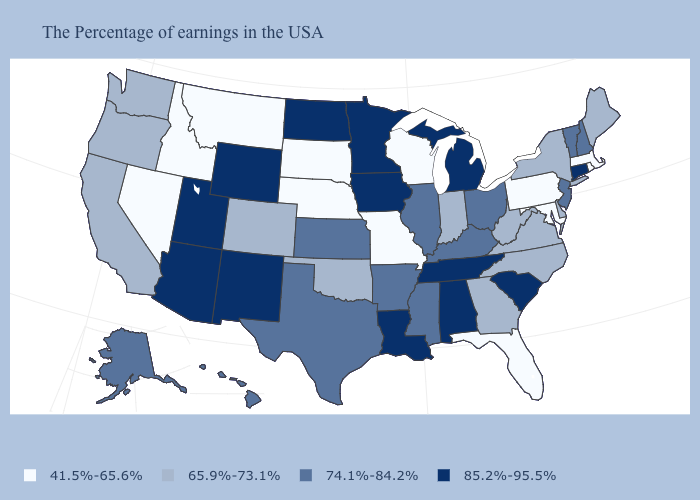What is the value of California?
Give a very brief answer. 65.9%-73.1%. How many symbols are there in the legend?
Be succinct. 4. Which states have the lowest value in the West?
Answer briefly. Montana, Idaho, Nevada. Name the states that have a value in the range 41.5%-65.6%?
Write a very short answer. Massachusetts, Rhode Island, Maryland, Pennsylvania, Florida, Wisconsin, Missouri, Nebraska, South Dakota, Montana, Idaho, Nevada. Name the states that have a value in the range 41.5%-65.6%?
Be succinct. Massachusetts, Rhode Island, Maryland, Pennsylvania, Florida, Wisconsin, Missouri, Nebraska, South Dakota, Montana, Idaho, Nevada. What is the value of South Dakota?
Be succinct. 41.5%-65.6%. Name the states that have a value in the range 74.1%-84.2%?
Short answer required. New Hampshire, Vermont, New Jersey, Ohio, Kentucky, Illinois, Mississippi, Arkansas, Kansas, Texas, Alaska, Hawaii. Name the states that have a value in the range 41.5%-65.6%?
Short answer required. Massachusetts, Rhode Island, Maryland, Pennsylvania, Florida, Wisconsin, Missouri, Nebraska, South Dakota, Montana, Idaho, Nevada. Name the states that have a value in the range 41.5%-65.6%?
Concise answer only. Massachusetts, Rhode Island, Maryland, Pennsylvania, Florida, Wisconsin, Missouri, Nebraska, South Dakota, Montana, Idaho, Nevada. Among the states that border South Dakota , which have the lowest value?
Write a very short answer. Nebraska, Montana. Does Montana have the lowest value in the West?
Concise answer only. Yes. What is the lowest value in states that border Iowa?
Write a very short answer. 41.5%-65.6%. What is the highest value in the West ?
Be succinct. 85.2%-95.5%. Name the states that have a value in the range 65.9%-73.1%?
Give a very brief answer. Maine, New York, Delaware, Virginia, North Carolina, West Virginia, Georgia, Indiana, Oklahoma, Colorado, California, Washington, Oregon. What is the value of Illinois?
Keep it brief. 74.1%-84.2%. 